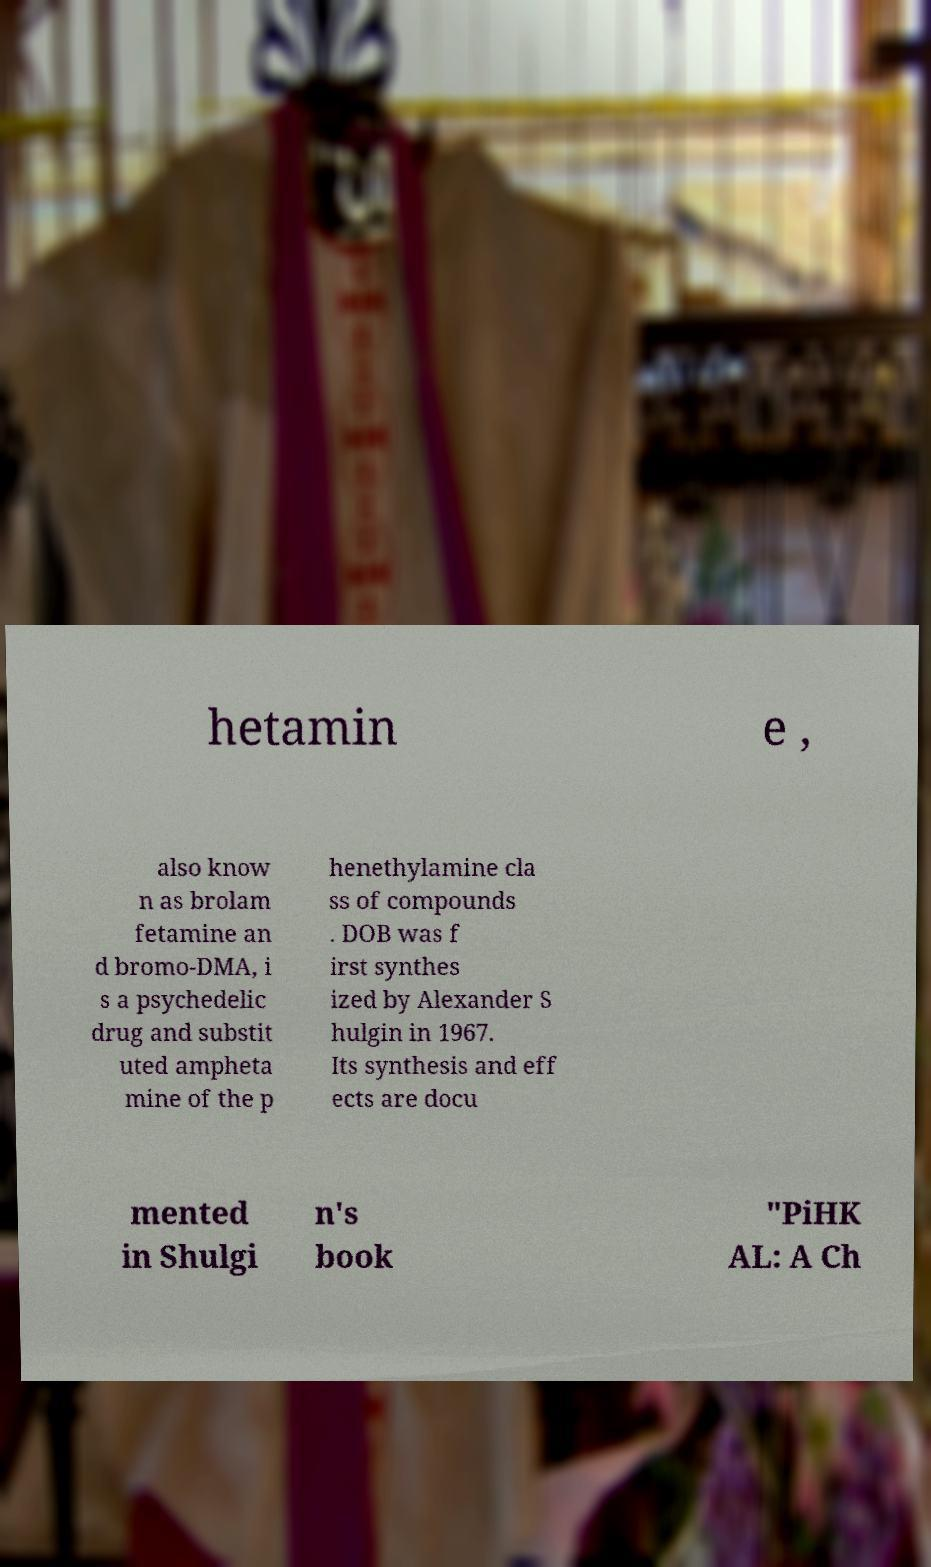Can you read and provide the text displayed in the image?This photo seems to have some interesting text. Can you extract and type it out for me? hetamin e , also know n as brolam fetamine an d bromo-DMA, i s a psychedelic drug and substit uted ampheta mine of the p henethylamine cla ss of compounds . DOB was f irst synthes ized by Alexander S hulgin in 1967. Its synthesis and eff ects are docu mented in Shulgi n's book "PiHK AL: A Ch 